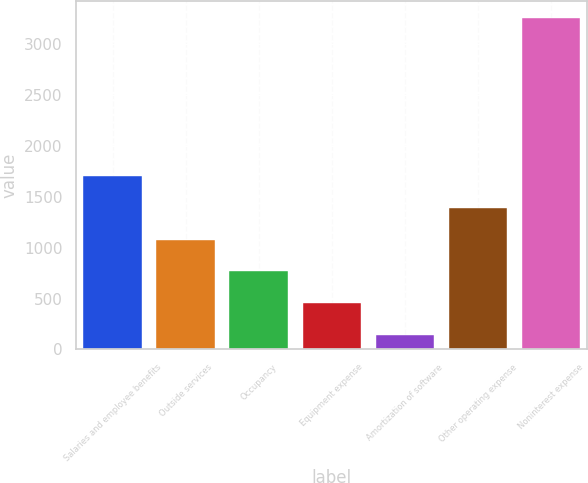<chart> <loc_0><loc_0><loc_500><loc_500><bar_chart><fcel>Salaries and employee benefits<fcel>Outside services<fcel>Occupancy<fcel>Equipment expense<fcel>Amortization of software<fcel>Other operating expense<fcel>Noninterest expense<nl><fcel>1702.5<fcel>1079.9<fcel>768.6<fcel>457.3<fcel>146<fcel>1391.2<fcel>3259<nl></chart> 